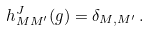Convert formula to latex. <formula><loc_0><loc_0><loc_500><loc_500>h ^ { J } _ { M M ^ { \prime } } ( g ) = \delta _ { M , M ^ { \prime } } \, .</formula> 